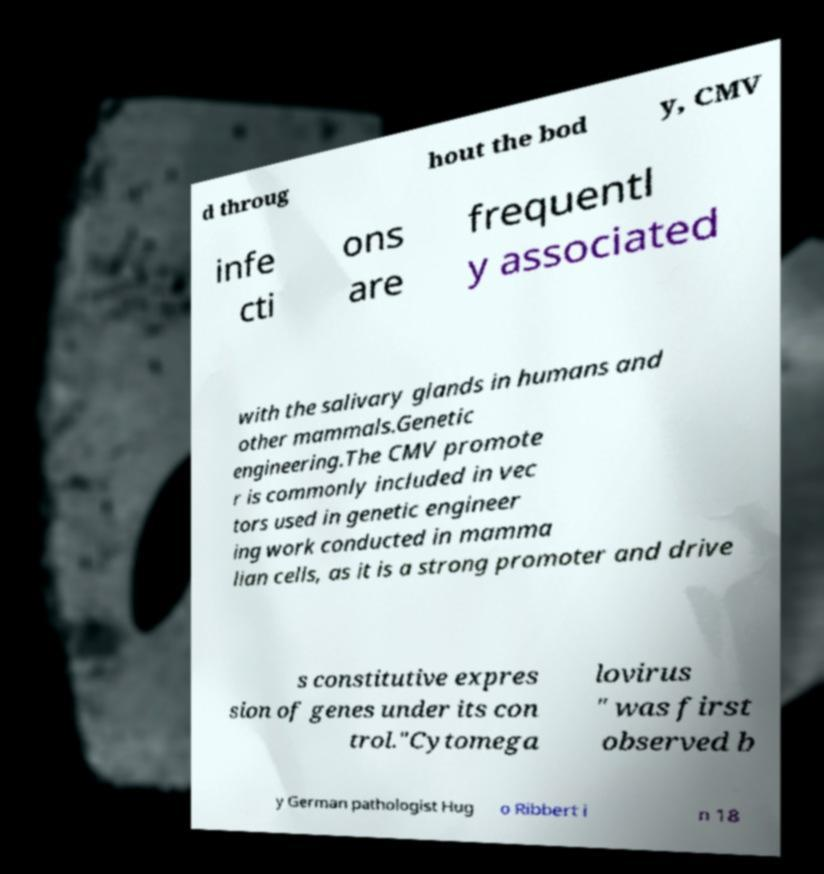Could you extract and type out the text from this image? d throug hout the bod y, CMV infe cti ons are frequentl y associated with the salivary glands in humans and other mammals.Genetic engineering.The CMV promote r is commonly included in vec tors used in genetic engineer ing work conducted in mamma lian cells, as it is a strong promoter and drive s constitutive expres sion of genes under its con trol."Cytomega lovirus " was first observed b y German pathologist Hug o Ribbert i n 18 